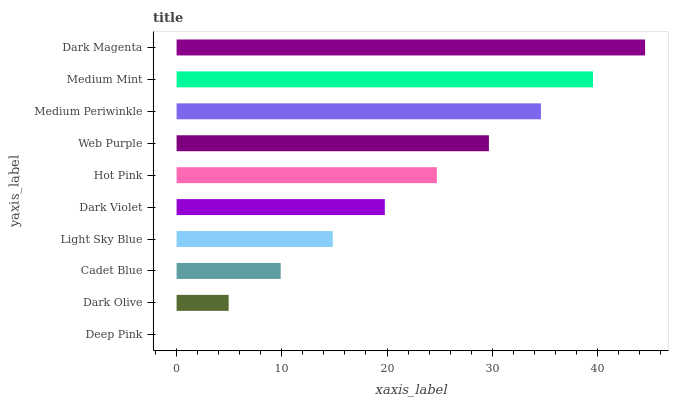Is Deep Pink the minimum?
Answer yes or no. Yes. Is Dark Magenta the maximum?
Answer yes or no. Yes. Is Dark Olive the minimum?
Answer yes or no. No. Is Dark Olive the maximum?
Answer yes or no. No. Is Dark Olive greater than Deep Pink?
Answer yes or no. Yes. Is Deep Pink less than Dark Olive?
Answer yes or no. Yes. Is Deep Pink greater than Dark Olive?
Answer yes or no. No. Is Dark Olive less than Deep Pink?
Answer yes or no. No. Is Hot Pink the high median?
Answer yes or no. Yes. Is Dark Violet the low median?
Answer yes or no. Yes. Is Light Sky Blue the high median?
Answer yes or no. No. Is Web Purple the low median?
Answer yes or no. No. 